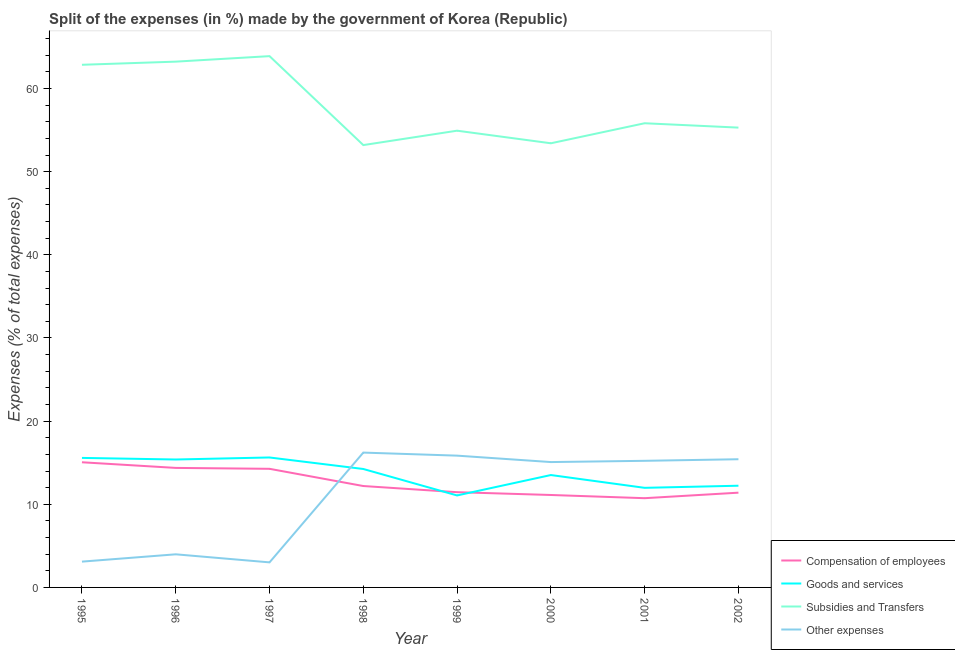How many different coloured lines are there?
Your answer should be very brief. 4. What is the percentage of amount spent on subsidies in 1998?
Give a very brief answer. 53.2. Across all years, what is the maximum percentage of amount spent on goods and services?
Your answer should be very brief. 15.63. Across all years, what is the minimum percentage of amount spent on goods and services?
Provide a succinct answer. 11.06. In which year was the percentage of amount spent on goods and services maximum?
Give a very brief answer. 1997. What is the total percentage of amount spent on goods and services in the graph?
Your answer should be compact. 109.63. What is the difference between the percentage of amount spent on subsidies in 2001 and that in 2002?
Provide a short and direct response. 0.52. What is the difference between the percentage of amount spent on other expenses in 2002 and the percentage of amount spent on goods and services in 1999?
Your response must be concise. 4.36. What is the average percentage of amount spent on goods and services per year?
Your answer should be very brief. 13.7. In the year 1997, what is the difference between the percentage of amount spent on other expenses and percentage of amount spent on goods and services?
Keep it short and to the point. -12.62. In how many years, is the percentage of amount spent on goods and services greater than 28 %?
Provide a succinct answer. 0. What is the ratio of the percentage of amount spent on goods and services in 1998 to that in 1999?
Provide a succinct answer. 1.29. Is the difference between the percentage of amount spent on other expenses in 1996 and 1998 greater than the difference between the percentage of amount spent on subsidies in 1996 and 1998?
Your answer should be compact. No. What is the difference between the highest and the second highest percentage of amount spent on other expenses?
Your response must be concise. 0.37. What is the difference between the highest and the lowest percentage of amount spent on subsidies?
Offer a terse response. 10.7. Is the percentage of amount spent on compensation of employees strictly greater than the percentage of amount spent on other expenses over the years?
Ensure brevity in your answer.  No. Does the graph contain any zero values?
Make the answer very short. No. Where does the legend appear in the graph?
Ensure brevity in your answer.  Bottom right. How many legend labels are there?
Offer a very short reply. 4. How are the legend labels stacked?
Make the answer very short. Vertical. What is the title of the graph?
Ensure brevity in your answer.  Split of the expenses (in %) made by the government of Korea (Republic). What is the label or title of the Y-axis?
Keep it short and to the point. Expenses (% of total expenses). What is the Expenses (% of total expenses) in Compensation of employees in 1995?
Your answer should be very brief. 15.05. What is the Expenses (% of total expenses) of Goods and services in 1995?
Provide a succinct answer. 15.58. What is the Expenses (% of total expenses) of Subsidies and Transfers in 1995?
Your answer should be compact. 62.86. What is the Expenses (% of total expenses) of Other expenses in 1995?
Ensure brevity in your answer.  3.1. What is the Expenses (% of total expenses) in Compensation of employees in 1996?
Provide a succinct answer. 14.37. What is the Expenses (% of total expenses) of Goods and services in 1996?
Offer a very short reply. 15.39. What is the Expenses (% of total expenses) of Subsidies and Transfers in 1996?
Give a very brief answer. 63.24. What is the Expenses (% of total expenses) in Other expenses in 1996?
Ensure brevity in your answer.  3.98. What is the Expenses (% of total expenses) in Compensation of employees in 1997?
Offer a very short reply. 14.27. What is the Expenses (% of total expenses) in Goods and services in 1997?
Provide a succinct answer. 15.63. What is the Expenses (% of total expenses) in Subsidies and Transfers in 1997?
Your answer should be compact. 63.9. What is the Expenses (% of total expenses) of Other expenses in 1997?
Ensure brevity in your answer.  3.01. What is the Expenses (% of total expenses) in Compensation of employees in 1998?
Make the answer very short. 12.2. What is the Expenses (% of total expenses) in Goods and services in 1998?
Keep it short and to the point. 14.24. What is the Expenses (% of total expenses) in Subsidies and Transfers in 1998?
Give a very brief answer. 53.2. What is the Expenses (% of total expenses) of Other expenses in 1998?
Your answer should be compact. 16.22. What is the Expenses (% of total expenses) of Compensation of employees in 1999?
Provide a short and direct response. 11.45. What is the Expenses (% of total expenses) of Goods and services in 1999?
Your answer should be compact. 11.06. What is the Expenses (% of total expenses) in Subsidies and Transfers in 1999?
Provide a succinct answer. 54.93. What is the Expenses (% of total expenses) in Other expenses in 1999?
Offer a terse response. 15.85. What is the Expenses (% of total expenses) of Compensation of employees in 2000?
Provide a short and direct response. 11.12. What is the Expenses (% of total expenses) in Goods and services in 2000?
Provide a short and direct response. 13.52. What is the Expenses (% of total expenses) in Subsidies and Transfers in 2000?
Offer a terse response. 53.42. What is the Expenses (% of total expenses) of Other expenses in 2000?
Offer a terse response. 15.08. What is the Expenses (% of total expenses) of Compensation of employees in 2001?
Your answer should be compact. 10.73. What is the Expenses (% of total expenses) in Goods and services in 2001?
Your response must be concise. 11.98. What is the Expenses (% of total expenses) in Subsidies and Transfers in 2001?
Your response must be concise. 55.83. What is the Expenses (% of total expenses) of Other expenses in 2001?
Your answer should be very brief. 15.23. What is the Expenses (% of total expenses) in Compensation of employees in 2002?
Provide a succinct answer. 11.4. What is the Expenses (% of total expenses) of Goods and services in 2002?
Provide a succinct answer. 12.23. What is the Expenses (% of total expenses) of Subsidies and Transfers in 2002?
Ensure brevity in your answer.  55.3. What is the Expenses (% of total expenses) of Other expenses in 2002?
Provide a succinct answer. 15.42. Across all years, what is the maximum Expenses (% of total expenses) in Compensation of employees?
Provide a short and direct response. 15.05. Across all years, what is the maximum Expenses (% of total expenses) of Goods and services?
Provide a succinct answer. 15.63. Across all years, what is the maximum Expenses (% of total expenses) of Subsidies and Transfers?
Provide a short and direct response. 63.9. Across all years, what is the maximum Expenses (% of total expenses) in Other expenses?
Your answer should be compact. 16.22. Across all years, what is the minimum Expenses (% of total expenses) in Compensation of employees?
Offer a very short reply. 10.73. Across all years, what is the minimum Expenses (% of total expenses) in Goods and services?
Make the answer very short. 11.06. Across all years, what is the minimum Expenses (% of total expenses) of Subsidies and Transfers?
Offer a very short reply. 53.2. Across all years, what is the minimum Expenses (% of total expenses) in Other expenses?
Make the answer very short. 3.01. What is the total Expenses (% of total expenses) of Compensation of employees in the graph?
Provide a short and direct response. 100.59. What is the total Expenses (% of total expenses) of Goods and services in the graph?
Ensure brevity in your answer.  109.63. What is the total Expenses (% of total expenses) of Subsidies and Transfers in the graph?
Your answer should be very brief. 462.68. What is the total Expenses (% of total expenses) in Other expenses in the graph?
Give a very brief answer. 87.89. What is the difference between the Expenses (% of total expenses) in Compensation of employees in 1995 and that in 1996?
Your response must be concise. 0.68. What is the difference between the Expenses (% of total expenses) of Goods and services in 1995 and that in 1996?
Keep it short and to the point. 0.19. What is the difference between the Expenses (% of total expenses) of Subsidies and Transfers in 1995 and that in 1996?
Ensure brevity in your answer.  -0.38. What is the difference between the Expenses (% of total expenses) in Other expenses in 1995 and that in 1996?
Provide a short and direct response. -0.88. What is the difference between the Expenses (% of total expenses) in Compensation of employees in 1995 and that in 1997?
Your answer should be very brief. 0.79. What is the difference between the Expenses (% of total expenses) in Goods and services in 1995 and that in 1997?
Provide a succinct answer. -0.05. What is the difference between the Expenses (% of total expenses) of Subsidies and Transfers in 1995 and that in 1997?
Give a very brief answer. -1.04. What is the difference between the Expenses (% of total expenses) of Other expenses in 1995 and that in 1997?
Give a very brief answer. 0.09. What is the difference between the Expenses (% of total expenses) of Compensation of employees in 1995 and that in 1998?
Make the answer very short. 2.86. What is the difference between the Expenses (% of total expenses) of Goods and services in 1995 and that in 1998?
Your response must be concise. 1.33. What is the difference between the Expenses (% of total expenses) of Subsidies and Transfers in 1995 and that in 1998?
Keep it short and to the point. 9.66. What is the difference between the Expenses (% of total expenses) of Other expenses in 1995 and that in 1998?
Provide a succinct answer. -13.11. What is the difference between the Expenses (% of total expenses) of Compensation of employees in 1995 and that in 1999?
Provide a succinct answer. 3.6. What is the difference between the Expenses (% of total expenses) of Goods and services in 1995 and that in 1999?
Your answer should be compact. 4.51. What is the difference between the Expenses (% of total expenses) in Subsidies and Transfers in 1995 and that in 1999?
Ensure brevity in your answer.  7.93. What is the difference between the Expenses (% of total expenses) in Other expenses in 1995 and that in 1999?
Keep it short and to the point. -12.75. What is the difference between the Expenses (% of total expenses) in Compensation of employees in 1995 and that in 2000?
Keep it short and to the point. 3.94. What is the difference between the Expenses (% of total expenses) of Goods and services in 1995 and that in 2000?
Give a very brief answer. 2.06. What is the difference between the Expenses (% of total expenses) of Subsidies and Transfers in 1995 and that in 2000?
Provide a succinct answer. 9.44. What is the difference between the Expenses (% of total expenses) of Other expenses in 1995 and that in 2000?
Your answer should be compact. -11.97. What is the difference between the Expenses (% of total expenses) in Compensation of employees in 1995 and that in 2001?
Make the answer very short. 4.32. What is the difference between the Expenses (% of total expenses) of Goods and services in 1995 and that in 2001?
Ensure brevity in your answer.  3.6. What is the difference between the Expenses (% of total expenses) in Subsidies and Transfers in 1995 and that in 2001?
Your answer should be compact. 7.03. What is the difference between the Expenses (% of total expenses) in Other expenses in 1995 and that in 2001?
Keep it short and to the point. -12.12. What is the difference between the Expenses (% of total expenses) in Compensation of employees in 1995 and that in 2002?
Give a very brief answer. 3.66. What is the difference between the Expenses (% of total expenses) of Goods and services in 1995 and that in 2002?
Provide a succinct answer. 3.35. What is the difference between the Expenses (% of total expenses) in Subsidies and Transfers in 1995 and that in 2002?
Make the answer very short. 7.56. What is the difference between the Expenses (% of total expenses) in Other expenses in 1995 and that in 2002?
Ensure brevity in your answer.  -12.31. What is the difference between the Expenses (% of total expenses) in Compensation of employees in 1996 and that in 1997?
Offer a terse response. 0.11. What is the difference between the Expenses (% of total expenses) in Goods and services in 1996 and that in 1997?
Your answer should be compact. -0.24. What is the difference between the Expenses (% of total expenses) of Subsidies and Transfers in 1996 and that in 1997?
Offer a very short reply. -0.66. What is the difference between the Expenses (% of total expenses) of Other expenses in 1996 and that in 1997?
Your response must be concise. 0.97. What is the difference between the Expenses (% of total expenses) of Compensation of employees in 1996 and that in 1998?
Give a very brief answer. 2.18. What is the difference between the Expenses (% of total expenses) of Goods and services in 1996 and that in 1998?
Offer a terse response. 1.14. What is the difference between the Expenses (% of total expenses) of Subsidies and Transfers in 1996 and that in 1998?
Provide a short and direct response. 10.04. What is the difference between the Expenses (% of total expenses) in Other expenses in 1996 and that in 1998?
Ensure brevity in your answer.  -12.23. What is the difference between the Expenses (% of total expenses) of Compensation of employees in 1996 and that in 1999?
Provide a succinct answer. 2.92. What is the difference between the Expenses (% of total expenses) of Goods and services in 1996 and that in 1999?
Make the answer very short. 4.32. What is the difference between the Expenses (% of total expenses) in Subsidies and Transfers in 1996 and that in 1999?
Make the answer very short. 8.3. What is the difference between the Expenses (% of total expenses) in Other expenses in 1996 and that in 1999?
Provide a succinct answer. -11.87. What is the difference between the Expenses (% of total expenses) in Compensation of employees in 1996 and that in 2000?
Provide a short and direct response. 3.26. What is the difference between the Expenses (% of total expenses) in Goods and services in 1996 and that in 2000?
Your response must be concise. 1.87. What is the difference between the Expenses (% of total expenses) of Subsidies and Transfers in 1996 and that in 2000?
Your response must be concise. 9.82. What is the difference between the Expenses (% of total expenses) in Other expenses in 1996 and that in 2000?
Keep it short and to the point. -11.1. What is the difference between the Expenses (% of total expenses) of Compensation of employees in 1996 and that in 2001?
Your answer should be very brief. 3.64. What is the difference between the Expenses (% of total expenses) of Goods and services in 1996 and that in 2001?
Keep it short and to the point. 3.41. What is the difference between the Expenses (% of total expenses) in Subsidies and Transfers in 1996 and that in 2001?
Your answer should be compact. 7.41. What is the difference between the Expenses (% of total expenses) of Other expenses in 1996 and that in 2001?
Provide a succinct answer. -11.24. What is the difference between the Expenses (% of total expenses) in Compensation of employees in 1996 and that in 2002?
Keep it short and to the point. 2.98. What is the difference between the Expenses (% of total expenses) of Goods and services in 1996 and that in 2002?
Your answer should be compact. 3.15. What is the difference between the Expenses (% of total expenses) of Subsidies and Transfers in 1996 and that in 2002?
Provide a short and direct response. 7.93. What is the difference between the Expenses (% of total expenses) in Other expenses in 1996 and that in 2002?
Your answer should be very brief. -11.44. What is the difference between the Expenses (% of total expenses) of Compensation of employees in 1997 and that in 1998?
Give a very brief answer. 2.07. What is the difference between the Expenses (% of total expenses) of Goods and services in 1997 and that in 1998?
Your answer should be compact. 1.38. What is the difference between the Expenses (% of total expenses) of Subsidies and Transfers in 1997 and that in 1998?
Ensure brevity in your answer.  10.7. What is the difference between the Expenses (% of total expenses) in Other expenses in 1997 and that in 1998?
Provide a succinct answer. -13.2. What is the difference between the Expenses (% of total expenses) of Compensation of employees in 1997 and that in 1999?
Provide a short and direct response. 2.81. What is the difference between the Expenses (% of total expenses) in Goods and services in 1997 and that in 1999?
Offer a very short reply. 4.57. What is the difference between the Expenses (% of total expenses) in Subsidies and Transfers in 1997 and that in 1999?
Your answer should be very brief. 8.97. What is the difference between the Expenses (% of total expenses) of Other expenses in 1997 and that in 1999?
Provide a succinct answer. -12.84. What is the difference between the Expenses (% of total expenses) of Compensation of employees in 1997 and that in 2000?
Make the answer very short. 3.15. What is the difference between the Expenses (% of total expenses) of Goods and services in 1997 and that in 2000?
Provide a short and direct response. 2.11. What is the difference between the Expenses (% of total expenses) of Subsidies and Transfers in 1997 and that in 2000?
Your response must be concise. 10.48. What is the difference between the Expenses (% of total expenses) of Other expenses in 1997 and that in 2000?
Provide a succinct answer. -12.06. What is the difference between the Expenses (% of total expenses) of Compensation of employees in 1997 and that in 2001?
Ensure brevity in your answer.  3.53. What is the difference between the Expenses (% of total expenses) in Goods and services in 1997 and that in 2001?
Keep it short and to the point. 3.65. What is the difference between the Expenses (% of total expenses) of Subsidies and Transfers in 1997 and that in 2001?
Your response must be concise. 8.07. What is the difference between the Expenses (% of total expenses) in Other expenses in 1997 and that in 2001?
Keep it short and to the point. -12.21. What is the difference between the Expenses (% of total expenses) in Compensation of employees in 1997 and that in 2002?
Ensure brevity in your answer.  2.87. What is the difference between the Expenses (% of total expenses) in Goods and services in 1997 and that in 2002?
Offer a terse response. 3.4. What is the difference between the Expenses (% of total expenses) of Subsidies and Transfers in 1997 and that in 2002?
Your answer should be very brief. 8.6. What is the difference between the Expenses (% of total expenses) of Other expenses in 1997 and that in 2002?
Provide a succinct answer. -12.4. What is the difference between the Expenses (% of total expenses) of Compensation of employees in 1998 and that in 1999?
Your answer should be very brief. 0.74. What is the difference between the Expenses (% of total expenses) in Goods and services in 1998 and that in 1999?
Your answer should be very brief. 3.18. What is the difference between the Expenses (% of total expenses) of Subsidies and Transfers in 1998 and that in 1999?
Give a very brief answer. -1.73. What is the difference between the Expenses (% of total expenses) of Other expenses in 1998 and that in 1999?
Ensure brevity in your answer.  0.37. What is the difference between the Expenses (% of total expenses) of Compensation of employees in 1998 and that in 2000?
Keep it short and to the point. 1.08. What is the difference between the Expenses (% of total expenses) in Goods and services in 1998 and that in 2000?
Keep it short and to the point. 0.73. What is the difference between the Expenses (% of total expenses) in Subsidies and Transfers in 1998 and that in 2000?
Offer a very short reply. -0.22. What is the difference between the Expenses (% of total expenses) in Other expenses in 1998 and that in 2000?
Provide a succinct answer. 1.14. What is the difference between the Expenses (% of total expenses) in Compensation of employees in 1998 and that in 2001?
Make the answer very short. 1.46. What is the difference between the Expenses (% of total expenses) in Goods and services in 1998 and that in 2001?
Your answer should be very brief. 2.27. What is the difference between the Expenses (% of total expenses) of Subsidies and Transfers in 1998 and that in 2001?
Provide a short and direct response. -2.63. What is the difference between the Expenses (% of total expenses) in Other expenses in 1998 and that in 2001?
Make the answer very short. 0.99. What is the difference between the Expenses (% of total expenses) of Compensation of employees in 1998 and that in 2002?
Offer a very short reply. 0.8. What is the difference between the Expenses (% of total expenses) in Goods and services in 1998 and that in 2002?
Provide a short and direct response. 2.01. What is the difference between the Expenses (% of total expenses) of Subsidies and Transfers in 1998 and that in 2002?
Offer a very short reply. -2.1. What is the difference between the Expenses (% of total expenses) in Other expenses in 1998 and that in 2002?
Keep it short and to the point. 0.8. What is the difference between the Expenses (% of total expenses) of Compensation of employees in 1999 and that in 2000?
Provide a short and direct response. 0.34. What is the difference between the Expenses (% of total expenses) of Goods and services in 1999 and that in 2000?
Provide a succinct answer. -2.45. What is the difference between the Expenses (% of total expenses) of Subsidies and Transfers in 1999 and that in 2000?
Give a very brief answer. 1.51. What is the difference between the Expenses (% of total expenses) in Other expenses in 1999 and that in 2000?
Offer a terse response. 0.77. What is the difference between the Expenses (% of total expenses) in Compensation of employees in 1999 and that in 2001?
Your response must be concise. 0.72. What is the difference between the Expenses (% of total expenses) in Goods and services in 1999 and that in 2001?
Offer a terse response. -0.92. What is the difference between the Expenses (% of total expenses) of Subsidies and Transfers in 1999 and that in 2001?
Your answer should be compact. -0.9. What is the difference between the Expenses (% of total expenses) of Other expenses in 1999 and that in 2001?
Your answer should be compact. 0.62. What is the difference between the Expenses (% of total expenses) in Compensation of employees in 1999 and that in 2002?
Give a very brief answer. 0.06. What is the difference between the Expenses (% of total expenses) in Goods and services in 1999 and that in 2002?
Offer a very short reply. -1.17. What is the difference between the Expenses (% of total expenses) in Subsidies and Transfers in 1999 and that in 2002?
Your answer should be compact. -0.37. What is the difference between the Expenses (% of total expenses) of Other expenses in 1999 and that in 2002?
Ensure brevity in your answer.  0.43. What is the difference between the Expenses (% of total expenses) in Compensation of employees in 2000 and that in 2001?
Ensure brevity in your answer.  0.38. What is the difference between the Expenses (% of total expenses) in Goods and services in 2000 and that in 2001?
Ensure brevity in your answer.  1.54. What is the difference between the Expenses (% of total expenses) in Subsidies and Transfers in 2000 and that in 2001?
Offer a terse response. -2.41. What is the difference between the Expenses (% of total expenses) of Other expenses in 2000 and that in 2001?
Your answer should be very brief. -0.15. What is the difference between the Expenses (% of total expenses) in Compensation of employees in 2000 and that in 2002?
Keep it short and to the point. -0.28. What is the difference between the Expenses (% of total expenses) in Goods and services in 2000 and that in 2002?
Make the answer very short. 1.29. What is the difference between the Expenses (% of total expenses) of Subsidies and Transfers in 2000 and that in 2002?
Give a very brief answer. -1.88. What is the difference between the Expenses (% of total expenses) in Other expenses in 2000 and that in 2002?
Your response must be concise. -0.34. What is the difference between the Expenses (% of total expenses) of Compensation of employees in 2001 and that in 2002?
Ensure brevity in your answer.  -0.66. What is the difference between the Expenses (% of total expenses) of Goods and services in 2001 and that in 2002?
Keep it short and to the point. -0.25. What is the difference between the Expenses (% of total expenses) in Subsidies and Transfers in 2001 and that in 2002?
Ensure brevity in your answer.  0.53. What is the difference between the Expenses (% of total expenses) in Other expenses in 2001 and that in 2002?
Keep it short and to the point. -0.19. What is the difference between the Expenses (% of total expenses) in Compensation of employees in 1995 and the Expenses (% of total expenses) in Goods and services in 1996?
Your response must be concise. -0.33. What is the difference between the Expenses (% of total expenses) of Compensation of employees in 1995 and the Expenses (% of total expenses) of Subsidies and Transfers in 1996?
Your response must be concise. -48.18. What is the difference between the Expenses (% of total expenses) of Compensation of employees in 1995 and the Expenses (% of total expenses) of Other expenses in 1996?
Keep it short and to the point. 11.07. What is the difference between the Expenses (% of total expenses) in Goods and services in 1995 and the Expenses (% of total expenses) in Subsidies and Transfers in 1996?
Your response must be concise. -47.66. What is the difference between the Expenses (% of total expenses) of Goods and services in 1995 and the Expenses (% of total expenses) of Other expenses in 1996?
Your answer should be compact. 11.6. What is the difference between the Expenses (% of total expenses) of Subsidies and Transfers in 1995 and the Expenses (% of total expenses) of Other expenses in 1996?
Give a very brief answer. 58.88. What is the difference between the Expenses (% of total expenses) in Compensation of employees in 1995 and the Expenses (% of total expenses) in Goods and services in 1997?
Give a very brief answer. -0.58. What is the difference between the Expenses (% of total expenses) in Compensation of employees in 1995 and the Expenses (% of total expenses) in Subsidies and Transfers in 1997?
Make the answer very short. -48.85. What is the difference between the Expenses (% of total expenses) in Compensation of employees in 1995 and the Expenses (% of total expenses) in Other expenses in 1997?
Provide a short and direct response. 12.04. What is the difference between the Expenses (% of total expenses) in Goods and services in 1995 and the Expenses (% of total expenses) in Subsidies and Transfers in 1997?
Make the answer very short. -48.32. What is the difference between the Expenses (% of total expenses) in Goods and services in 1995 and the Expenses (% of total expenses) in Other expenses in 1997?
Keep it short and to the point. 12.56. What is the difference between the Expenses (% of total expenses) in Subsidies and Transfers in 1995 and the Expenses (% of total expenses) in Other expenses in 1997?
Your answer should be very brief. 59.84. What is the difference between the Expenses (% of total expenses) of Compensation of employees in 1995 and the Expenses (% of total expenses) of Goods and services in 1998?
Your answer should be compact. 0.81. What is the difference between the Expenses (% of total expenses) in Compensation of employees in 1995 and the Expenses (% of total expenses) in Subsidies and Transfers in 1998?
Make the answer very short. -38.15. What is the difference between the Expenses (% of total expenses) of Compensation of employees in 1995 and the Expenses (% of total expenses) of Other expenses in 1998?
Ensure brevity in your answer.  -1.16. What is the difference between the Expenses (% of total expenses) in Goods and services in 1995 and the Expenses (% of total expenses) in Subsidies and Transfers in 1998?
Offer a terse response. -37.62. What is the difference between the Expenses (% of total expenses) in Goods and services in 1995 and the Expenses (% of total expenses) in Other expenses in 1998?
Your answer should be compact. -0.64. What is the difference between the Expenses (% of total expenses) of Subsidies and Transfers in 1995 and the Expenses (% of total expenses) of Other expenses in 1998?
Offer a very short reply. 46.64. What is the difference between the Expenses (% of total expenses) of Compensation of employees in 1995 and the Expenses (% of total expenses) of Goods and services in 1999?
Offer a terse response. 3.99. What is the difference between the Expenses (% of total expenses) in Compensation of employees in 1995 and the Expenses (% of total expenses) in Subsidies and Transfers in 1999?
Give a very brief answer. -39.88. What is the difference between the Expenses (% of total expenses) of Compensation of employees in 1995 and the Expenses (% of total expenses) of Other expenses in 1999?
Make the answer very short. -0.8. What is the difference between the Expenses (% of total expenses) of Goods and services in 1995 and the Expenses (% of total expenses) of Subsidies and Transfers in 1999?
Your response must be concise. -39.35. What is the difference between the Expenses (% of total expenses) of Goods and services in 1995 and the Expenses (% of total expenses) of Other expenses in 1999?
Your answer should be very brief. -0.27. What is the difference between the Expenses (% of total expenses) in Subsidies and Transfers in 1995 and the Expenses (% of total expenses) in Other expenses in 1999?
Provide a short and direct response. 47.01. What is the difference between the Expenses (% of total expenses) of Compensation of employees in 1995 and the Expenses (% of total expenses) of Goods and services in 2000?
Your answer should be very brief. 1.54. What is the difference between the Expenses (% of total expenses) of Compensation of employees in 1995 and the Expenses (% of total expenses) of Subsidies and Transfers in 2000?
Make the answer very short. -38.37. What is the difference between the Expenses (% of total expenses) of Compensation of employees in 1995 and the Expenses (% of total expenses) of Other expenses in 2000?
Provide a short and direct response. -0.02. What is the difference between the Expenses (% of total expenses) in Goods and services in 1995 and the Expenses (% of total expenses) in Subsidies and Transfers in 2000?
Your answer should be compact. -37.84. What is the difference between the Expenses (% of total expenses) of Goods and services in 1995 and the Expenses (% of total expenses) of Other expenses in 2000?
Offer a terse response. 0.5. What is the difference between the Expenses (% of total expenses) of Subsidies and Transfers in 1995 and the Expenses (% of total expenses) of Other expenses in 2000?
Ensure brevity in your answer.  47.78. What is the difference between the Expenses (% of total expenses) of Compensation of employees in 1995 and the Expenses (% of total expenses) of Goods and services in 2001?
Ensure brevity in your answer.  3.08. What is the difference between the Expenses (% of total expenses) of Compensation of employees in 1995 and the Expenses (% of total expenses) of Subsidies and Transfers in 2001?
Provide a short and direct response. -40.77. What is the difference between the Expenses (% of total expenses) of Compensation of employees in 1995 and the Expenses (% of total expenses) of Other expenses in 2001?
Provide a succinct answer. -0.17. What is the difference between the Expenses (% of total expenses) in Goods and services in 1995 and the Expenses (% of total expenses) in Subsidies and Transfers in 2001?
Provide a succinct answer. -40.25. What is the difference between the Expenses (% of total expenses) in Goods and services in 1995 and the Expenses (% of total expenses) in Other expenses in 2001?
Provide a succinct answer. 0.35. What is the difference between the Expenses (% of total expenses) in Subsidies and Transfers in 1995 and the Expenses (% of total expenses) in Other expenses in 2001?
Ensure brevity in your answer.  47.63. What is the difference between the Expenses (% of total expenses) of Compensation of employees in 1995 and the Expenses (% of total expenses) of Goods and services in 2002?
Your answer should be very brief. 2.82. What is the difference between the Expenses (% of total expenses) of Compensation of employees in 1995 and the Expenses (% of total expenses) of Subsidies and Transfers in 2002?
Provide a succinct answer. -40.25. What is the difference between the Expenses (% of total expenses) in Compensation of employees in 1995 and the Expenses (% of total expenses) in Other expenses in 2002?
Provide a short and direct response. -0.37. What is the difference between the Expenses (% of total expenses) in Goods and services in 1995 and the Expenses (% of total expenses) in Subsidies and Transfers in 2002?
Offer a very short reply. -39.72. What is the difference between the Expenses (% of total expenses) of Goods and services in 1995 and the Expenses (% of total expenses) of Other expenses in 2002?
Your answer should be compact. 0.16. What is the difference between the Expenses (% of total expenses) of Subsidies and Transfers in 1995 and the Expenses (% of total expenses) of Other expenses in 2002?
Make the answer very short. 47.44. What is the difference between the Expenses (% of total expenses) in Compensation of employees in 1996 and the Expenses (% of total expenses) in Goods and services in 1997?
Your answer should be compact. -1.26. What is the difference between the Expenses (% of total expenses) of Compensation of employees in 1996 and the Expenses (% of total expenses) of Subsidies and Transfers in 1997?
Keep it short and to the point. -49.52. What is the difference between the Expenses (% of total expenses) in Compensation of employees in 1996 and the Expenses (% of total expenses) in Other expenses in 1997?
Provide a short and direct response. 11.36. What is the difference between the Expenses (% of total expenses) in Goods and services in 1996 and the Expenses (% of total expenses) in Subsidies and Transfers in 1997?
Your answer should be compact. -48.51. What is the difference between the Expenses (% of total expenses) in Goods and services in 1996 and the Expenses (% of total expenses) in Other expenses in 1997?
Make the answer very short. 12.37. What is the difference between the Expenses (% of total expenses) in Subsidies and Transfers in 1996 and the Expenses (% of total expenses) in Other expenses in 1997?
Offer a very short reply. 60.22. What is the difference between the Expenses (% of total expenses) in Compensation of employees in 1996 and the Expenses (% of total expenses) in Goods and services in 1998?
Provide a succinct answer. 0.13. What is the difference between the Expenses (% of total expenses) in Compensation of employees in 1996 and the Expenses (% of total expenses) in Subsidies and Transfers in 1998?
Your answer should be very brief. -38.83. What is the difference between the Expenses (% of total expenses) in Compensation of employees in 1996 and the Expenses (% of total expenses) in Other expenses in 1998?
Your response must be concise. -1.84. What is the difference between the Expenses (% of total expenses) of Goods and services in 1996 and the Expenses (% of total expenses) of Subsidies and Transfers in 1998?
Your answer should be very brief. -37.81. What is the difference between the Expenses (% of total expenses) in Goods and services in 1996 and the Expenses (% of total expenses) in Other expenses in 1998?
Provide a succinct answer. -0.83. What is the difference between the Expenses (% of total expenses) in Subsidies and Transfers in 1996 and the Expenses (% of total expenses) in Other expenses in 1998?
Your answer should be compact. 47.02. What is the difference between the Expenses (% of total expenses) of Compensation of employees in 1996 and the Expenses (% of total expenses) of Goods and services in 1999?
Offer a very short reply. 3.31. What is the difference between the Expenses (% of total expenses) in Compensation of employees in 1996 and the Expenses (% of total expenses) in Subsidies and Transfers in 1999?
Offer a terse response. -40.56. What is the difference between the Expenses (% of total expenses) in Compensation of employees in 1996 and the Expenses (% of total expenses) in Other expenses in 1999?
Offer a very short reply. -1.47. What is the difference between the Expenses (% of total expenses) of Goods and services in 1996 and the Expenses (% of total expenses) of Subsidies and Transfers in 1999?
Offer a terse response. -39.55. What is the difference between the Expenses (% of total expenses) of Goods and services in 1996 and the Expenses (% of total expenses) of Other expenses in 1999?
Offer a terse response. -0.46. What is the difference between the Expenses (% of total expenses) in Subsidies and Transfers in 1996 and the Expenses (% of total expenses) in Other expenses in 1999?
Keep it short and to the point. 47.39. What is the difference between the Expenses (% of total expenses) of Compensation of employees in 1996 and the Expenses (% of total expenses) of Goods and services in 2000?
Your answer should be compact. 0.86. What is the difference between the Expenses (% of total expenses) in Compensation of employees in 1996 and the Expenses (% of total expenses) in Subsidies and Transfers in 2000?
Make the answer very short. -39.04. What is the difference between the Expenses (% of total expenses) in Compensation of employees in 1996 and the Expenses (% of total expenses) in Other expenses in 2000?
Offer a very short reply. -0.7. What is the difference between the Expenses (% of total expenses) in Goods and services in 1996 and the Expenses (% of total expenses) in Subsidies and Transfers in 2000?
Your answer should be very brief. -38.03. What is the difference between the Expenses (% of total expenses) of Goods and services in 1996 and the Expenses (% of total expenses) of Other expenses in 2000?
Provide a succinct answer. 0.31. What is the difference between the Expenses (% of total expenses) of Subsidies and Transfers in 1996 and the Expenses (% of total expenses) of Other expenses in 2000?
Provide a short and direct response. 48.16. What is the difference between the Expenses (% of total expenses) in Compensation of employees in 1996 and the Expenses (% of total expenses) in Goods and services in 2001?
Make the answer very short. 2.4. What is the difference between the Expenses (% of total expenses) in Compensation of employees in 1996 and the Expenses (% of total expenses) in Subsidies and Transfers in 2001?
Ensure brevity in your answer.  -41.45. What is the difference between the Expenses (% of total expenses) of Compensation of employees in 1996 and the Expenses (% of total expenses) of Other expenses in 2001?
Ensure brevity in your answer.  -0.85. What is the difference between the Expenses (% of total expenses) in Goods and services in 1996 and the Expenses (% of total expenses) in Subsidies and Transfers in 2001?
Your answer should be compact. -40.44. What is the difference between the Expenses (% of total expenses) in Goods and services in 1996 and the Expenses (% of total expenses) in Other expenses in 2001?
Offer a very short reply. 0.16. What is the difference between the Expenses (% of total expenses) in Subsidies and Transfers in 1996 and the Expenses (% of total expenses) in Other expenses in 2001?
Give a very brief answer. 48.01. What is the difference between the Expenses (% of total expenses) in Compensation of employees in 1996 and the Expenses (% of total expenses) in Goods and services in 2002?
Make the answer very short. 2.14. What is the difference between the Expenses (% of total expenses) in Compensation of employees in 1996 and the Expenses (% of total expenses) in Subsidies and Transfers in 2002?
Provide a short and direct response. -40.93. What is the difference between the Expenses (% of total expenses) of Compensation of employees in 1996 and the Expenses (% of total expenses) of Other expenses in 2002?
Your answer should be compact. -1.04. What is the difference between the Expenses (% of total expenses) in Goods and services in 1996 and the Expenses (% of total expenses) in Subsidies and Transfers in 2002?
Your answer should be compact. -39.92. What is the difference between the Expenses (% of total expenses) in Goods and services in 1996 and the Expenses (% of total expenses) in Other expenses in 2002?
Make the answer very short. -0.03. What is the difference between the Expenses (% of total expenses) in Subsidies and Transfers in 1996 and the Expenses (% of total expenses) in Other expenses in 2002?
Your answer should be compact. 47.82. What is the difference between the Expenses (% of total expenses) of Compensation of employees in 1997 and the Expenses (% of total expenses) of Goods and services in 1998?
Provide a succinct answer. 0.02. What is the difference between the Expenses (% of total expenses) of Compensation of employees in 1997 and the Expenses (% of total expenses) of Subsidies and Transfers in 1998?
Your answer should be compact. -38.93. What is the difference between the Expenses (% of total expenses) in Compensation of employees in 1997 and the Expenses (% of total expenses) in Other expenses in 1998?
Offer a terse response. -1.95. What is the difference between the Expenses (% of total expenses) in Goods and services in 1997 and the Expenses (% of total expenses) in Subsidies and Transfers in 1998?
Your answer should be compact. -37.57. What is the difference between the Expenses (% of total expenses) in Goods and services in 1997 and the Expenses (% of total expenses) in Other expenses in 1998?
Offer a very short reply. -0.59. What is the difference between the Expenses (% of total expenses) of Subsidies and Transfers in 1997 and the Expenses (% of total expenses) of Other expenses in 1998?
Give a very brief answer. 47.68. What is the difference between the Expenses (% of total expenses) of Compensation of employees in 1997 and the Expenses (% of total expenses) of Goods and services in 1999?
Provide a short and direct response. 3.2. What is the difference between the Expenses (% of total expenses) in Compensation of employees in 1997 and the Expenses (% of total expenses) in Subsidies and Transfers in 1999?
Give a very brief answer. -40.67. What is the difference between the Expenses (% of total expenses) of Compensation of employees in 1997 and the Expenses (% of total expenses) of Other expenses in 1999?
Provide a succinct answer. -1.58. What is the difference between the Expenses (% of total expenses) of Goods and services in 1997 and the Expenses (% of total expenses) of Subsidies and Transfers in 1999?
Provide a short and direct response. -39.3. What is the difference between the Expenses (% of total expenses) of Goods and services in 1997 and the Expenses (% of total expenses) of Other expenses in 1999?
Ensure brevity in your answer.  -0.22. What is the difference between the Expenses (% of total expenses) in Subsidies and Transfers in 1997 and the Expenses (% of total expenses) in Other expenses in 1999?
Your answer should be compact. 48.05. What is the difference between the Expenses (% of total expenses) of Compensation of employees in 1997 and the Expenses (% of total expenses) of Goods and services in 2000?
Give a very brief answer. 0.75. What is the difference between the Expenses (% of total expenses) of Compensation of employees in 1997 and the Expenses (% of total expenses) of Subsidies and Transfers in 2000?
Make the answer very short. -39.15. What is the difference between the Expenses (% of total expenses) of Compensation of employees in 1997 and the Expenses (% of total expenses) of Other expenses in 2000?
Give a very brief answer. -0.81. What is the difference between the Expenses (% of total expenses) of Goods and services in 1997 and the Expenses (% of total expenses) of Subsidies and Transfers in 2000?
Provide a short and direct response. -37.79. What is the difference between the Expenses (% of total expenses) of Goods and services in 1997 and the Expenses (% of total expenses) of Other expenses in 2000?
Provide a succinct answer. 0.55. What is the difference between the Expenses (% of total expenses) of Subsidies and Transfers in 1997 and the Expenses (% of total expenses) of Other expenses in 2000?
Provide a short and direct response. 48.82. What is the difference between the Expenses (% of total expenses) of Compensation of employees in 1997 and the Expenses (% of total expenses) of Goods and services in 2001?
Provide a succinct answer. 2.29. What is the difference between the Expenses (% of total expenses) of Compensation of employees in 1997 and the Expenses (% of total expenses) of Subsidies and Transfers in 2001?
Provide a short and direct response. -41.56. What is the difference between the Expenses (% of total expenses) in Compensation of employees in 1997 and the Expenses (% of total expenses) in Other expenses in 2001?
Offer a very short reply. -0.96. What is the difference between the Expenses (% of total expenses) in Goods and services in 1997 and the Expenses (% of total expenses) in Subsidies and Transfers in 2001?
Your answer should be compact. -40.2. What is the difference between the Expenses (% of total expenses) of Goods and services in 1997 and the Expenses (% of total expenses) of Other expenses in 2001?
Offer a very short reply. 0.4. What is the difference between the Expenses (% of total expenses) in Subsidies and Transfers in 1997 and the Expenses (% of total expenses) in Other expenses in 2001?
Provide a short and direct response. 48.67. What is the difference between the Expenses (% of total expenses) of Compensation of employees in 1997 and the Expenses (% of total expenses) of Goods and services in 2002?
Offer a very short reply. 2.03. What is the difference between the Expenses (% of total expenses) of Compensation of employees in 1997 and the Expenses (% of total expenses) of Subsidies and Transfers in 2002?
Give a very brief answer. -41.04. What is the difference between the Expenses (% of total expenses) in Compensation of employees in 1997 and the Expenses (% of total expenses) in Other expenses in 2002?
Your answer should be compact. -1.15. What is the difference between the Expenses (% of total expenses) of Goods and services in 1997 and the Expenses (% of total expenses) of Subsidies and Transfers in 2002?
Give a very brief answer. -39.67. What is the difference between the Expenses (% of total expenses) of Goods and services in 1997 and the Expenses (% of total expenses) of Other expenses in 2002?
Offer a terse response. 0.21. What is the difference between the Expenses (% of total expenses) of Subsidies and Transfers in 1997 and the Expenses (% of total expenses) of Other expenses in 2002?
Your response must be concise. 48.48. What is the difference between the Expenses (% of total expenses) in Compensation of employees in 1998 and the Expenses (% of total expenses) in Goods and services in 1999?
Your response must be concise. 1.13. What is the difference between the Expenses (% of total expenses) in Compensation of employees in 1998 and the Expenses (% of total expenses) in Subsidies and Transfers in 1999?
Your answer should be very brief. -42.74. What is the difference between the Expenses (% of total expenses) in Compensation of employees in 1998 and the Expenses (% of total expenses) in Other expenses in 1999?
Provide a succinct answer. -3.65. What is the difference between the Expenses (% of total expenses) of Goods and services in 1998 and the Expenses (% of total expenses) of Subsidies and Transfers in 1999?
Provide a short and direct response. -40.69. What is the difference between the Expenses (% of total expenses) of Goods and services in 1998 and the Expenses (% of total expenses) of Other expenses in 1999?
Your answer should be compact. -1.6. What is the difference between the Expenses (% of total expenses) in Subsidies and Transfers in 1998 and the Expenses (% of total expenses) in Other expenses in 1999?
Your answer should be compact. 37.35. What is the difference between the Expenses (% of total expenses) of Compensation of employees in 1998 and the Expenses (% of total expenses) of Goods and services in 2000?
Your answer should be very brief. -1.32. What is the difference between the Expenses (% of total expenses) in Compensation of employees in 1998 and the Expenses (% of total expenses) in Subsidies and Transfers in 2000?
Provide a succinct answer. -41.22. What is the difference between the Expenses (% of total expenses) in Compensation of employees in 1998 and the Expenses (% of total expenses) in Other expenses in 2000?
Give a very brief answer. -2.88. What is the difference between the Expenses (% of total expenses) in Goods and services in 1998 and the Expenses (% of total expenses) in Subsidies and Transfers in 2000?
Ensure brevity in your answer.  -39.17. What is the difference between the Expenses (% of total expenses) in Goods and services in 1998 and the Expenses (% of total expenses) in Other expenses in 2000?
Your response must be concise. -0.83. What is the difference between the Expenses (% of total expenses) in Subsidies and Transfers in 1998 and the Expenses (% of total expenses) in Other expenses in 2000?
Provide a short and direct response. 38.12. What is the difference between the Expenses (% of total expenses) in Compensation of employees in 1998 and the Expenses (% of total expenses) in Goods and services in 2001?
Provide a short and direct response. 0.22. What is the difference between the Expenses (% of total expenses) in Compensation of employees in 1998 and the Expenses (% of total expenses) in Subsidies and Transfers in 2001?
Make the answer very short. -43.63. What is the difference between the Expenses (% of total expenses) of Compensation of employees in 1998 and the Expenses (% of total expenses) of Other expenses in 2001?
Provide a succinct answer. -3.03. What is the difference between the Expenses (% of total expenses) of Goods and services in 1998 and the Expenses (% of total expenses) of Subsidies and Transfers in 2001?
Your answer should be compact. -41.58. What is the difference between the Expenses (% of total expenses) of Goods and services in 1998 and the Expenses (% of total expenses) of Other expenses in 2001?
Offer a terse response. -0.98. What is the difference between the Expenses (% of total expenses) of Subsidies and Transfers in 1998 and the Expenses (% of total expenses) of Other expenses in 2001?
Your answer should be very brief. 37.97. What is the difference between the Expenses (% of total expenses) in Compensation of employees in 1998 and the Expenses (% of total expenses) in Goods and services in 2002?
Provide a short and direct response. -0.04. What is the difference between the Expenses (% of total expenses) of Compensation of employees in 1998 and the Expenses (% of total expenses) of Subsidies and Transfers in 2002?
Provide a succinct answer. -43.11. What is the difference between the Expenses (% of total expenses) in Compensation of employees in 1998 and the Expenses (% of total expenses) in Other expenses in 2002?
Ensure brevity in your answer.  -3.22. What is the difference between the Expenses (% of total expenses) in Goods and services in 1998 and the Expenses (% of total expenses) in Subsidies and Transfers in 2002?
Ensure brevity in your answer.  -41.06. What is the difference between the Expenses (% of total expenses) of Goods and services in 1998 and the Expenses (% of total expenses) of Other expenses in 2002?
Your answer should be very brief. -1.17. What is the difference between the Expenses (% of total expenses) in Subsidies and Transfers in 1998 and the Expenses (% of total expenses) in Other expenses in 2002?
Offer a very short reply. 37.78. What is the difference between the Expenses (% of total expenses) of Compensation of employees in 1999 and the Expenses (% of total expenses) of Goods and services in 2000?
Your answer should be compact. -2.06. What is the difference between the Expenses (% of total expenses) of Compensation of employees in 1999 and the Expenses (% of total expenses) of Subsidies and Transfers in 2000?
Ensure brevity in your answer.  -41.96. What is the difference between the Expenses (% of total expenses) in Compensation of employees in 1999 and the Expenses (% of total expenses) in Other expenses in 2000?
Provide a succinct answer. -3.62. What is the difference between the Expenses (% of total expenses) of Goods and services in 1999 and the Expenses (% of total expenses) of Subsidies and Transfers in 2000?
Make the answer very short. -42.36. What is the difference between the Expenses (% of total expenses) of Goods and services in 1999 and the Expenses (% of total expenses) of Other expenses in 2000?
Your answer should be very brief. -4.01. What is the difference between the Expenses (% of total expenses) of Subsidies and Transfers in 1999 and the Expenses (% of total expenses) of Other expenses in 2000?
Your answer should be very brief. 39.85. What is the difference between the Expenses (% of total expenses) of Compensation of employees in 1999 and the Expenses (% of total expenses) of Goods and services in 2001?
Ensure brevity in your answer.  -0.52. What is the difference between the Expenses (% of total expenses) in Compensation of employees in 1999 and the Expenses (% of total expenses) in Subsidies and Transfers in 2001?
Provide a succinct answer. -44.37. What is the difference between the Expenses (% of total expenses) of Compensation of employees in 1999 and the Expenses (% of total expenses) of Other expenses in 2001?
Your answer should be compact. -3.77. What is the difference between the Expenses (% of total expenses) in Goods and services in 1999 and the Expenses (% of total expenses) in Subsidies and Transfers in 2001?
Your response must be concise. -44.76. What is the difference between the Expenses (% of total expenses) of Goods and services in 1999 and the Expenses (% of total expenses) of Other expenses in 2001?
Ensure brevity in your answer.  -4.16. What is the difference between the Expenses (% of total expenses) of Subsidies and Transfers in 1999 and the Expenses (% of total expenses) of Other expenses in 2001?
Make the answer very short. 39.7. What is the difference between the Expenses (% of total expenses) of Compensation of employees in 1999 and the Expenses (% of total expenses) of Goods and services in 2002?
Make the answer very short. -0.78. What is the difference between the Expenses (% of total expenses) in Compensation of employees in 1999 and the Expenses (% of total expenses) in Subsidies and Transfers in 2002?
Ensure brevity in your answer.  -43.85. What is the difference between the Expenses (% of total expenses) in Compensation of employees in 1999 and the Expenses (% of total expenses) in Other expenses in 2002?
Ensure brevity in your answer.  -3.96. What is the difference between the Expenses (% of total expenses) of Goods and services in 1999 and the Expenses (% of total expenses) of Subsidies and Transfers in 2002?
Provide a succinct answer. -44.24. What is the difference between the Expenses (% of total expenses) of Goods and services in 1999 and the Expenses (% of total expenses) of Other expenses in 2002?
Your response must be concise. -4.36. What is the difference between the Expenses (% of total expenses) in Subsidies and Transfers in 1999 and the Expenses (% of total expenses) in Other expenses in 2002?
Provide a short and direct response. 39.51. What is the difference between the Expenses (% of total expenses) of Compensation of employees in 2000 and the Expenses (% of total expenses) of Goods and services in 2001?
Provide a short and direct response. -0.86. What is the difference between the Expenses (% of total expenses) in Compensation of employees in 2000 and the Expenses (% of total expenses) in Subsidies and Transfers in 2001?
Provide a succinct answer. -44.71. What is the difference between the Expenses (% of total expenses) in Compensation of employees in 2000 and the Expenses (% of total expenses) in Other expenses in 2001?
Provide a succinct answer. -4.11. What is the difference between the Expenses (% of total expenses) of Goods and services in 2000 and the Expenses (% of total expenses) of Subsidies and Transfers in 2001?
Give a very brief answer. -42.31. What is the difference between the Expenses (% of total expenses) of Goods and services in 2000 and the Expenses (% of total expenses) of Other expenses in 2001?
Provide a short and direct response. -1.71. What is the difference between the Expenses (% of total expenses) in Subsidies and Transfers in 2000 and the Expenses (% of total expenses) in Other expenses in 2001?
Give a very brief answer. 38.19. What is the difference between the Expenses (% of total expenses) of Compensation of employees in 2000 and the Expenses (% of total expenses) of Goods and services in 2002?
Your response must be concise. -1.11. What is the difference between the Expenses (% of total expenses) in Compensation of employees in 2000 and the Expenses (% of total expenses) in Subsidies and Transfers in 2002?
Keep it short and to the point. -44.18. What is the difference between the Expenses (% of total expenses) in Compensation of employees in 2000 and the Expenses (% of total expenses) in Other expenses in 2002?
Give a very brief answer. -4.3. What is the difference between the Expenses (% of total expenses) of Goods and services in 2000 and the Expenses (% of total expenses) of Subsidies and Transfers in 2002?
Provide a short and direct response. -41.78. What is the difference between the Expenses (% of total expenses) in Goods and services in 2000 and the Expenses (% of total expenses) in Other expenses in 2002?
Give a very brief answer. -1.9. What is the difference between the Expenses (% of total expenses) of Subsidies and Transfers in 2000 and the Expenses (% of total expenses) of Other expenses in 2002?
Give a very brief answer. 38. What is the difference between the Expenses (% of total expenses) of Compensation of employees in 2001 and the Expenses (% of total expenses) of Goods and services in 2002?
Ensure brevity in your answer.  -1.5. What is the difference between the Expenses (% of total expenses) of Compensation of employees in 2001 and the Expenses (% of total expenses) of Subsidies and Transfers in 2002?
Your response must be concise. -44.57. What is the difference between the Expenses (% of total expenses) in Compensation of employees in 2001 and the Expenses (% of total expenses) in Other expenses in 2002?
Make the answer very short. -4.69. What is the difference between the Expenses (% of total expenses) in Goods and services in 2001 and the Expenses (% of total expenses) in Subsidies and Transfers in 2002?
Your response must be concise. -43.32. What is the difference between the Expenses (% of total expenses) of Goods and services in 2001 and the Expenses (% of total expenses) of Other expenses in 2002?
Give a very brief answer. -3.44. What is the difference between the Expenses (% of total expenses) in Subsidies and Transfers in 2001 and the Expenses (% of total expenses) in Other expenses in 2002?
Keep it short and to the point. 40.41. What is the average Expenses (% of total expenses) of Compensation of employees per year?
Your response must be concise. 12.57. What is the average Expenses (% of total expenses) of Goods and services per year?
Offer a very short reply. 13.7. What is the average Expenses (% of total expenses) in Subsidies and Transfers per year?
Ensure brevity in your answer.  57.83. What is the average Expenses (% of total expenses) in Other expenses per year?
Provide a short and direct response. 10.99. In the year 1995, what is the difference between the Expenses (% of total expenses) of Compensation of employees and Expenses (% of total expenses) of Goods and services?
Offer a very short reply. -0.52. In the year 1995, what is the difference between the Expenses (% of total expenses) in Compensation of employees and Expenses (% of total expenses) in Subsidies and Transfers?
Ensure brevity in your answer.  -47.8. In the year 1995, what is the difference between the Expenses (% of total expenses) of Compensation of employees and Expenses (% of total expenses) of Other expenses?
Your response must be concise. 11.95. In the year 1995, what is the difference between the Expenses (% of total expenses) in Goods and services and Expenses (% of total expenses) in Subsidies and Transfers?
Keep it short and to the point. -47.28. In the year 1995, what is the difference between the Expenses (% of total expenses) in Goods and services and Expenses (% of total expenses) in Other expenses?
Offer a very short reply. 12.47. In the year 1995, what is the difference between the Expenses (% of total expenses) of Subsidies and Transfers and Expenses (% of total expenses) of Other expenses?
Make the answer very short. 59.75. In the year 1996, what is the difference between the Expenses (% of total expenses) of Compensation of employees and Expenses (% of total expenses) of Goods and services?
Offer a very short reply. -1.01. In the year 1996, what is the difference between the Expenses (% of total expenses) in Compensation of employees and Expenses (% of total expenses) in Subsidies and Transfers?
Keep it short and to the point. -48.86. In the year 1996, what is the difference between the Expenses (% of total expenses) of Compensation of employees and Expenses (% of total expenses) of Other expenses?
Keep it short and to the point. 10.39. In the year 1996, what is the difference between the Expenses (% of total expenses) in Goods and services and Expenses (% of total expenses) in Subsidies and Transfers?
Offer a terse response. -47.85. In the year 1996, what is the difference between the Expenses (% of total expenses) of Goods and services and Expenses (% of total expenses) of Other expenses?
Offer a very short reply. 11.4. In the year 1996, what is the difference between the Expenses (% of total expenses) of Subsidies and Transfers and Expenses (% of total expenses) of Other expenses?
Offer a very short reply. 59.25. In the year 1997, what is the difference between the Expenses (% of total expenses) of Compensation of employees and Expenses (% of total expenses) of Goods and services?
Your answer should be very brief. -1.36. In the year 1997, what is the difference between the Expenses (% of total expenses) of Compensation of employees and Expenses (% of total expenses) of Subsidies and Transfers?
Keep it short and to the point. -49.63. In the year 1997, what is the difference between the Expenses (% of total expenses) in Compensation of employees and Expenses (% of total expenses) in Other expenses?
Provide a short and direct response. 11.25. In the year 1997, what is the difference between the Expenses (% of total expenses) of Goods and services and Expenses (% of total expenses) of Subsidies and Transfers?
Your response must be concise. -48.27. In the year 1997, what is the difference between the Expenses (% of total expenses) in Goods and services and Expenses (% of total expenses) in Other expenses?
Your response must be concise. 12.62. In the year 1997, what is the difference between the Expenses (% of total expenses) of Subsidies and Transfers and Expenses (% of total expenses) of Other expenses?
Offer a very short reply. 60.88. In the year 1998, what is the difference between the Expenses (% of total expenses) of Compensation of employees and Expenses (% of total expenses) of Goods and services?
Offer a very short reply. -2.05. In the year 1998, what is the difference between the Expenses (% of total expenses) in Compensation of employees and Expenses (% of total expenses) in Subsidies and Transfers?
Your answer should be compact. -41. In the year 1998, what is the difference between the Expenses (% of total expenses) of Compensation of employees and Expenses (% of total expenses) of Other expenses?
Your response must be concise. -4.02. In the year 1998, what is the difference between the Expenses (% of total expenses) of Goods and services and Expenses (% of total expenses) of Subsidies and Transfers?
Offer a very short reply. -38.96. In the year 1998, what is the difference between the Expenses (% of total expenses) of Goods and services and Expenses (% of total expenses) of Other expenses?
Ensure brevity in your answer.  -1.97. In the year 1998, what is the difference between the Expenses (% of total expenses) in Subsidies and Transfers and Expenses (% of total expenses) in Other expenses?
Your response must be concise. 36.98. In the year 1999, what is the difference between the Expenses (% of total expenses) in Compensation of employees and Expenses (% of total expenses) in Goods and services?
Keep it short and to the point. 0.39. In the year 1999, what is the difference between the Expenses (% of total expenses) in Compensation of employees and Expenses (% of total expenses) in Subsidies and Transfers?
Make the answer very short. -43.48. In the year 1999, what is the difference between the Expenses (% of total expenses) of Compensation of employees and Expenses (% of total expenses) of Other expenses?
Offer a terse response. -4.4. In the year 1999, what is the difference between the Expenses (% of total expenses) in Goods and services and Expenses (% of total expenses) in Subsidies and Transfers?
Ensure brevity in your answer.  -43.87. In the year 1999, what is the difference between the Expenses (% of total expenses) in Goods and services and Expenses (% of total expenses) in Other expenses?
Your answer should be very brief. -4.79. In the year 1999, what is the difference between the Expenses (% of total expenses) of Subsidies and Transfers and Expenses (% of total expenses) of Other expenses?
Your answer should be compact. 39.08. In the year 2000, what is the difference between the Expenses (% of total expenses) of Compensation of employees and Expenses (% of total expenses) of Goods and services?
Offer a terse response. -2.4. In the year 2000, what is the difference between the Expenses (% of total expenses) of Compensation of employees and Expenses (% of total expenses) of Subsidies and Transfers?
Your answer should be very brief. -42.3. In the year 2000, what is the difference between the Expenses (% of total expenses) of Compensation of employees and Expenses (% of total expenses) of Other expenses?
Make the answer very short. -3.96. In the year 2000, what is the difference between the Expenses (% of total expenses) of Goods and services and Expenses (% of total expenses) of Subsidies and Transfers?
Your answer should be compact. -39.9. In the year 2000, what is the difference between the Expenses (% of total expenses) of Goods and services and Expenses (% of total expenses) of Other expenses?
Your answer should be compact. -1.56. In the year 2000, what is the difference between the Expenses (% of total expenses) of Subsidies and Transfers and Expenses (% of total expenses) of Other expenses?
Offer a very short reply. 38.34. In the year 2001, what is the difference between the Expenses (% of total expenses) of Compensation of employees and Expenses (% of total expenses) of Goods and services?
Your answer should be compact. -1.24. In the year 2001, what is the difference between the Expenses (% of total expenses) in Compensation of employees and Expenses (% of total expenses) in Subsidies and Transfers?
Your answer should be very brief. -45.09. In the year 2001, what is the difference between the Expenses (% of total expenses) of Compensation of employees and Expenses (% of total expenses) of Other expenses?
Provide a succinct answer. -4.49. In the year 2001, what is the difference between the Expenses (% of total expenses) of Goods and services and Expenses (% of total expenses) of Subsidies and Transfers?
Give a very brief answer. -43.85. In the year 2001, what is the difference between the Expenses (% of total expenses) in Goods and services and Expenses (% of total expenses) in Other expenses?
Keep it short and to the point. -3.25. In the year 2001, what is the difference between the Expenses (% of total expenses) of Subsidies and Transfers and Expenses (% of total expenses) of Other expenses?
Your response must be concise. 40.6. In the year 2002, what is the difference between the Expenses (% of total expenses) of Compensation of employees and Expenses (% of total expenses) of Goods and services?
Provide a succinct answer. -0.84. In the year 2002, what is the difference between the Expenses (% of total expenses) in Compensation of employees and Expenses (% of total expenses) in Subsidies and Transfers?
Your response must be concise. -43.91. In the year 2002, what is the difference between the Expenses (% of total expenses) in Compensation of employees and Expenses (% of total expenses) in Other expenses?
Your answer should be compact. -4.02. In the year 2002, what is the difference between the Expenses (% of total expenses) in Goods and services and Expenses (% of total expenses) in Subsidies and Transfers?
Your answer should be very brief. -43.07. In the year 2002, what is the difference between the Expenses (% of total expenses) of Goods and services and Expenses (% of total expenses) of Other expenses?
Give a very brief answer. -3.19. In the year 2002, what is the difference between the Expenses (% of total expenses) in Subsidies and Transfers and Expenses (% of total expenses) in Other expenses?
Provide a succinct answer. 39.88. What is the ratio of the Expenses (% of total expenses) of Compensation of employees in 1995 to that in 1996?
Your response must be concise. 1.05. What is the ratio of the Expenses (% of total expenses) of Goods and services in 1995 to that in 1996?
Offer a very short reply. 1.01. What is the ratio of the Expenses (% of total expenses) in Other expenses in 1995 to that in 1996?
Your answer should be very brief. 0.78. What is the ratio of the Expenses (% of total expenses) of Compensation of employees in 1995 to that in 1997?
Your answer should be compact. 1.06. What is the ratio of the Expenses (% of total expenses) of Subsidies and Transfers in 1995 to that in 1997?
Your answer should be compact. 0.98. What is the ratio of the Expenses (% of total expenses) in Other expenses in 1995 to that in 1997?
Give a very brief answer. 1.03. What is the ratio of the Expenses (% of total expenses) of Compensation of employees in 1995 to that in 1998?
Your answer should be very brief. 1.23. What is the ratio of the Expenses (% of total expenses) in Goods and services in 1995 to that in 1998?
Keep it short and to the point. 1.09. What is the ratio of the Expenses (% of total expenses) of Subsidies and Transfers in 1995 to that in 1998?
Make the answer very short. 1.18. What is the ratio of the Expenses (% of total expenses) of Other expenses in 1995 to that in 1998?
Your answer should be compact. 0.19. What is the ratio of the Expenses (% of total expenses) in Compensation of employees in 1995 to that in 1999?
Give a very brief answer. 1.31. What is the ratio of the Expenses (% of total expenses) in Goods and services in 1995 to that in 1999?
Provide a short and direct response. 1.41. What is the ratio of the Expenses (% of total expenses) in Subsidies and Transfers in 1995 to that in 1999?
Make the answer very short. 1.14. What is the ratio of the Expenses (% of total expenses) of Other expenses in 1995 to that in 1999?
Offer a very short reply. 0.2. What is the ratio of the Expenses (% of total expenses) in Compensation of employees in 1995 to that in 2000?
Offer a very short reply. 1.35. What is the ratio of the Expenses (% of total expenses) in Goods and services in 1995 to that in 2000?
Make the answer very short. 1.15. What is the ratio of the Expenses (% of total expenses) in Subsidies and Transfers in 1995 to that in 2000?
Make the answer very short. 1.18. What is the ratio of the Expenses (% of total expenses) of Other expenses in 1995 to that in 2000?
Keep it short and to the point. 0.21. What is the ratio of the Expenses (% of total expenses) of Compensation of employees in 1995 to that in 2001?
Offer a very short reply. 1.4. What is the ratio of the Expenses (% of total expenses) in Goods and services in 1995 to that in 2001?
Provide a succinct answer. 1.3. What is the ratio of the Expenses (% of total expenses) in Subsidies and Transfers in 1995 to that in 2001?
Provide a short and direct response. 1.13. What is the ratio of the Expenses (% of total expenses) of Other expenses in 1995 to that in 2001?
Your answer should be very brief. 0.2. What is the ratio of the Expenses (% of total expenses) in Compensation of employees in 1995 to that in 2002?
Your answer should be very brief. 1.32. What is the ratio of the Expenses (% of total expenses) of Goods and services in 1995 to that in 2002?
Your answer should be very brief. 1.27. What is the ratio of the Expenses (% of total expenses) of Subsidies and Transfers in 1995 to that in 2002?
Provide a succinct answer. 1.14. What is the ratio of the Expenses (% of total expenses) of Other expenses in 1995 to that in 2002?
Offer a terse response. 0.2. What is the ratio of the Expenses (% of total expenses) in Compensation of employees in 1996 to that in 1997?
Provide a succinct answer. 1.01. What is the ratio of the Expenses (% of total expenses) in Goods and services in 1996 to that in 1997?
Your answer should be compact. 0.98. What is the ratio of the Expenses (% of total expenses) of Other expenses in 1996 to that in 1997?
Provide a short and direct response. 1.32. What is the ratio of the Expenses (% of total expenses) in Compensation of employees in 1996 to that in 1998?
Your answer should be very brief. 1.18. What is the ratio of the Expenses (% of total expenses) in Goods and services in 1996 to that in 1998?
Ensure brevity in your answer.  1.08. What is the ratio of the Expenses (% of total expenses) in Subsidies and Transfers in 1996 to that in 1998?
Keep it short and to the point. 1.19. What is the ratio of the Expenses (% of total expenses) of Other expenses in 1996 to that in 1998?
Your answer should be very brief. 0.25. What is the ratio of the Expenses (% of total expenses) of Compensation of employees in 1996 to that in 1999?
Your answer should be compact. 1.25. What is the ratio of the Expenses (% of total expenses) of Goods and services in 1996 to that in 1999?
Your answer should be very brief. 1.39. What is the ratio of the Expenses (% of total expenses) in Subsidies and Transfers in 1996 to that in 1999?
Offer a very short reply. 1.15. What is the ratio of the Expenses (% of total expenses) of Other expenses in 1996 to that in 1999?
Provide a short and direct response. 0.25. What is the ratio of the Expenses (% of total expenses) in Compensation of employees in 1996 to that in 2000?
Keep it short and to the point. 1.29. What is the ratio of the Expenses (% of total expenses) of Goods and services in 1996 to that in 2000?
Provide a succinct answer. 1.14. What is the ratio of the Expenses (% of total expenses) in Subsidies and Transfers in 1996 to that in 2000?
Your answer should be compact. 1.18. What is the ratio of the Expenses (% of total expenses) of Other expenses in 1996 to that in 2000?
Your answer should be compact. 0.26. What is the ratio of the Expenses (% of total expenses) of Compensation of employees in 1996 to that in 2001?
Ensure brevity in your answer.  1.34. What is the ratio of the Expenses (% of total expenses) in Goods and services in 1996 to that in 2001?
Your answer should be compact. 1.28. What is the ratio of the Expenses (% of total expenses) of Subsidies and Transfers in 1996 to that in 2001?
Provide a succinct answer. 1.13. What is the ratio of the Expenses (% of total expenses) in Other expenses in 1996 to that in 2001?
Your answer should be very brief. 0.26. What is the ratio of the Expenses (% of total expenses) in Compensation of employees in 1996 to that in 2002?
Your answer should be very brief. 1.26. What is the ratio of the Expenses (% of total expenses) in Goods and services in 1996 to that in 2002?
Your response must be concise. 1.26. What is the ratio of the Expenses (% of total expenses) in Subsidies and Transfers in 1996 to that in 2002?
Make the answer very short. 1.14. What is the ratio of the Expenses (% of total expenses) in Other expenses in 1996 to that in 2002?
Your answer should be very brief. 0.26. What is the ratio of the Expenses (% of total expenses) of Compensation of employees in 1997 to that in 1998?
Make the answer very short. 1.17. What is the ratio of the Expenses (% of total expenses) of Goods and services in 1997 to that in 1998?
Offer a very short reply. 1.1. What is the ratio of the Expenses (% of total expenses) of Subsidies and Transfers in 1997 to that in 1998?
Give a very brief answer. 1.2. What is the ratio of the Expenses (% of total expenses) of Other expenses in 1997 to that in 1998?
Offer a very short reply. 0.19. What is the ratio of the Expenses (% of total expenses) in Compensation of employees in 1997 to that in 1999?
Offer a terse response. 1.25. What is the ratio of the Expenses (% of total expenses) of Goods and services in 1997 to that in 1999?
Your response must be concise. 1.41. What is the ratio of the Expenses (% of total expenses) in Subsidies and Transfers in 1997 to that in 1999?
Offer a terse response. 1.16. What is the ratio of the Expenses (% of total expenses) in Other expenses in 1997 to that in 1999?
Offer a very short reply. 0.19. What is the ratio of the Expenses (% of total expenses) of Compensation of employees in 1997 to that in 2000?
Provide a succinct answer. 1.28. What is the ratio of the Expenses (% of total expenses) of Goods and services in 1997 to that in 2000?
Make the answer very short. 1.16. What is the ratio of the Expenses (% of total expenses) of Subsidies and Transfers in 1997 to that in 2000?
Keep it short and to the point. 1.2. What is the ratio of the Expenses (% of total expenses) in Other expenses in 1997 to that in 2000?
Offer a terse response. 0.2. What is the ratio of the Expenses (% of total expenses) in Compensation of employees in 1997 to that in 2001?
Keep it short and to the point. 1.33. What is the ratio of the Expenses (% of total expenses) of Goods and services in 1997 to that in 2001?
Provide a short and direct response. 1.3. What is the ratio of the Expenses (% of total expenses) in Subsidies and Transfers in 1997 to that in 2001?
Your answer should be compact. 1.14. What is the ratio of the Expenses (% of total expenses) of Other expenses in 1997 to that in 2001?
Your answer should be very brief. 0.2. What is the ratio of the Expenses (% of total expenses) in Compensation of employees in 1997 to that in 2002?
Offer a very short reply. 1.25. What is the ratio of the Expenses (% of total expenses) of Goods and services in 1997 to that in 2002?
Ensure brevity in your answer.  1.28. What is the ratio of the Expenses (% of total expenses) of Subsidies and Transfers in 1997 to that in 2002?
Ensure brevity in your answer.  1.16. What is the ratio of the Expenses (% of total expenses) in Other expenses in 1997 to that in 2002?
Keep it short and to the point. 0.2. What is the ratio of the Expenses (% of total expenses) of Compensation of employees in 1998 to that in 1999?
Provide a succinct answer. 1.06. What is the ratio of the Expenses (% of total expenses) of Goods and services in 1998 to that in 1999?
Provide a succinct answer. 1.29. What is the ratio of the Expenses (% of total expenses) in Subsidies and Transfers in 1998 to that in 1999?
Your answer should be compact. 0.97. What is the ratio of the Expenses (% of total expenses) of Other expenses in 1998 to that in 1999?
Your answer should be very brief. 1.02. What is the ratio of the Expenses (% of total expenses) in Compensation of employees in 1998 to that in 2000?
Provide a short and direct response. 1.1. What is the ratio of the Expenses (% of total expenses) of Goods and services in 1998 to that in 2000?
Keep it short and to the point. 1.05. What is the ratio of the Expenses (% of total expenses) of Other expenses in 1998 to that in 2000?
Offer a terse response. 1.08. What is the ratio of the Expenses (% of total expenses) in Compensation of employees in 1998 to that in 2001?
Your answer should be compact. 1.14. What is the ratio of the Expenses (% of total expenses) in Goods and services in 1998 to that in 2001?
Ensure brevity in your answer.  1.19. What is the ratio of the Expenses (% of total expenses) in Subsidies and Transfers in 1998 to that in 2001?
Provide a short and direct response. 0.95. What is the ratio of the Expenses (% of total expenses) of Other expenses in 1998 to that in 2001?
Provide a short and direct response. 1.06. What is the ratio of the Expenses (% of total expenses) of Compensation of employees in 1998 to that in 2002?
Provide a short and direct response. 1.07. What is the ratio of the Expenses (% of total expenses) of Goods and services in 1998 to that in 2002?
Ensure brevity in your answer.  1.16. What is the ratio of the Expenses (% of total expenses) of Subsidies and Transfers in 1998 to that in 2002?
Your response must be concise. 0.96. What is the ratio of the Expenses (% of total expenses) in Other expenses in 1998 to that in 2002?
Your answer should be compact. 1.05. What is the ratio of the Expenses (% of total expenses) of Compensation of employees in 1999 to that in 2000?
Provide a succinct answer. 1.03. What is the ratio of the Expenses (% of total expenses) of Goods and services in 1999 to that in 2000?
Provide a succinct answer. 0.82. What is the ratio of the Expenses (% of total expenses) of Subsidies and Transfers in 1999 to that in 2000?
Your answer should be very brief. 1.03. What is the ratio of the Expenses (% of total expenses) in Other expenses in 1999 to that in 2000?
Ensure brevity in your answer.  1.05. What is the ratio of the Expenses (% of total expenses) in Compensation of employees in 1999 to that in 2001?
Ensure brevity in your answer.  1.07. What is the ratio of the Expenses (% of total expenses) of Goods and services in 1999 to that in 2001?
Offer a terse response. 0.92. What is the ratio of the Expenses (% of total expenses) of Subsidies and Transfers in 1999 to that in 2001?
Provide a short and direct response. 0.98. What is the ratio of the Expenses (% of total expenses) in Other expenses in 1999 to that in 2001?
Ensure brevity in your answer.  1.04. What is the ratio of the Expenses (% of total expenses) of Compensation of employees in 1999 to that in 2002?
Keep it short and to the point. 1.01. What is the ratio of the Expenses (% of total expenses) of Goods and services in 1999 to that in 2002?
Offer a terse response. 0.9. What is the ratio of the Expenses (% of total expenses) in Other expenses in 1999 to that in 2002?
Your response must be concise. 1.03. What is the ratio of the Expenses (% of total expenses) in Compensation of employees in 2000 to that in 2001?
Make the answer very short. 1.04. What is the ratio of the Expenses (% of total expenses) of Goods and services in 2000 to that in 2001?
Make the answer very short. 1.13. What is the ratio of the Expenses (% of total expenses) in Subsidies and Transfers in 2000 to that in 2001?
Ensure brevity in your answer.  0.96. What is the ratio of the Expenses (% of total expenses) of Other expenses in 2000 to that in 2001?
Provide a short and direct response. 0.99. What is the ratio of the Expenses (% of total expenses) of Compensation of employees in 2000 to that in 2002?
Your answer should be compact. 0.98. What is the ratio of the Expenses (% of total expenses) of Goods and services in 2000 to that in 2002?
Your answer should be compact. 1.11. What is the ratio of the Expenses (% of total expenses) in Subsidies and Transfers in 2000 to that in 2002?
Ensure brevity in your answer.  0.97. What is the ratio of the Expenses (% of total expenses) of Other expenses in 2000 to that in 2002?
Keep it short and to the point. 0.98. What is the ratio of the Expenses (% of total expenses) of Compensation of employees in 2001 to that in 2002?
Your answer should be compact. 0.94. What is the ratio of the Expenses (% of total expenses) in Goods and services in 2001 to that in 2002?
Offer a very short reply. 0.98. What is the ratio of the Expenses (% of total expenses) in Subsidies and Transfers in 2001 to that in 2002?
Your answer should be very brief. 1.01. What is the ratio of the Expenses (% of total expenses) of Other expenses in 2001 to that in 2002?
Provide a succinct answer. 0.99. What is the difference between the highest and the second highest Expenses (% of total expenses) in Compensation of employees?
Keep it short and to the point. 0.68. What is the difference between the highest and the second highest Expenses (% of total expenses) of Goods and services?
Provide a succinct answer. 0.05. What is the difference between the highest and the second highest Expenses (% of total expenses) of Subsidies and Transfers?
Your answer should be compact. 0.66. What is the difference between the highest and the second highest Expenses (% of total expenses) of Other expenses?
Offer a terse response. 0.37. What is the difference between the highest and the lowest Expenses (% of total expenses) of Compensation of employees?
Ensure brevity in your answer.  4.32. What is the difference between the highest and the lowest Expenses (% of total expenses) of Goods and services?
Offer a terse response. 4.57. What is the difference between the highest and the lowest Expenses (% of total expenses) of Subsidies and Transfers?
Ensure brevity in your answer.  10.7. What is the difference between the highest and the lowest Expenses (% of total expenses) in Other expenses?
Offer a terse response. 13.2. 